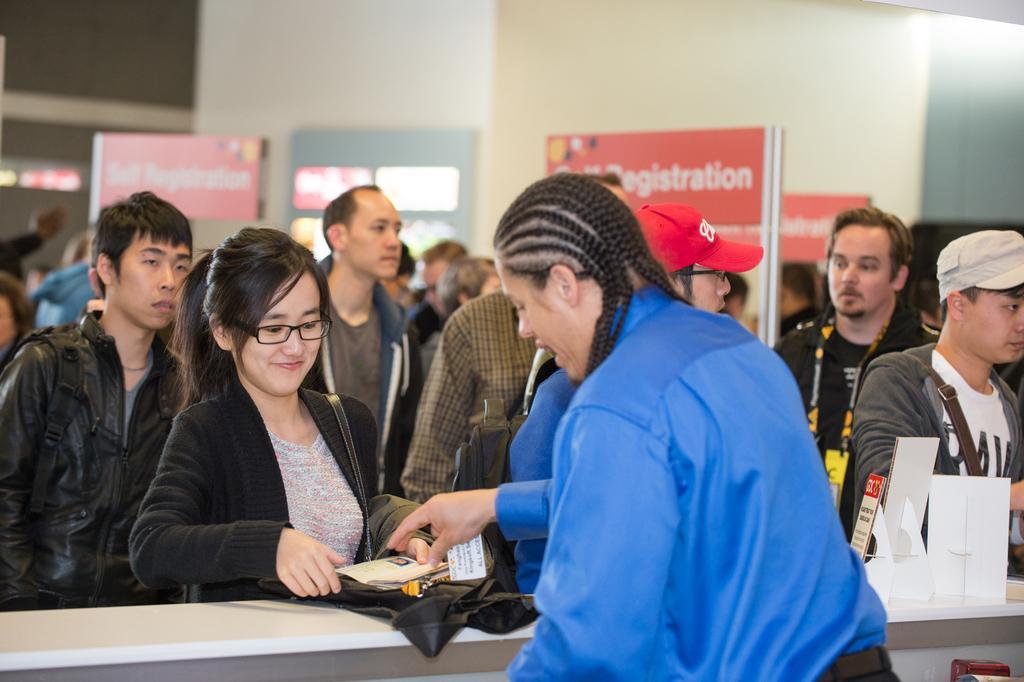In one or two sentences, can you explain what this image depicts? In this picture we can see a group of people and in the background we can see name boards,wall. 